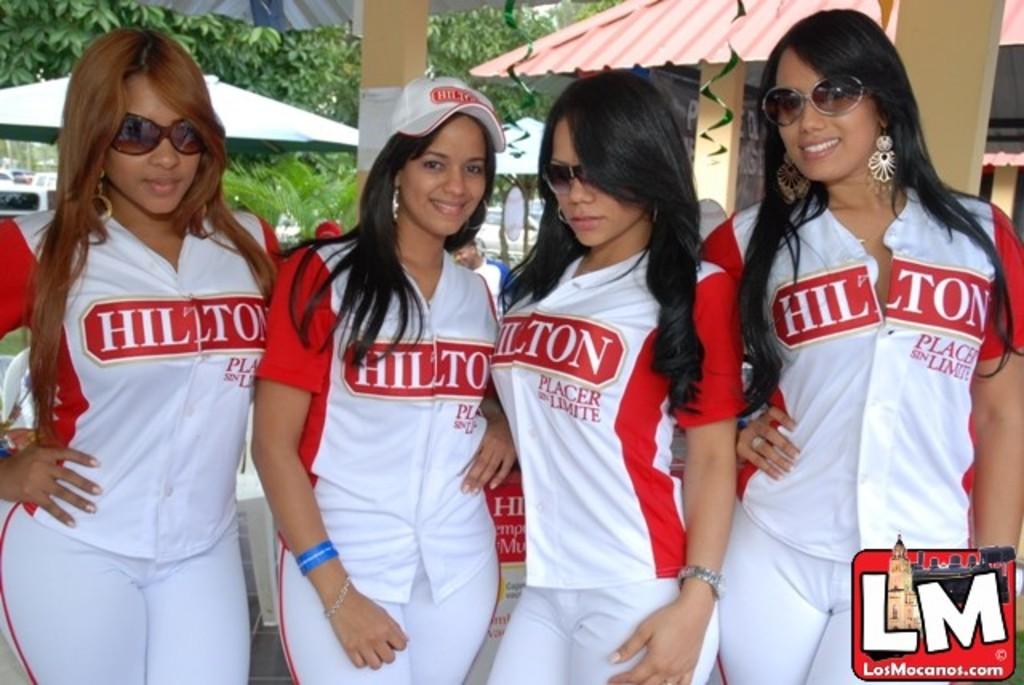Who is the sponsor of this team?
Provide a short and direct response. Hilton. What website hosts this photo?
Keep it short and to the point. Losmocanos.com. 